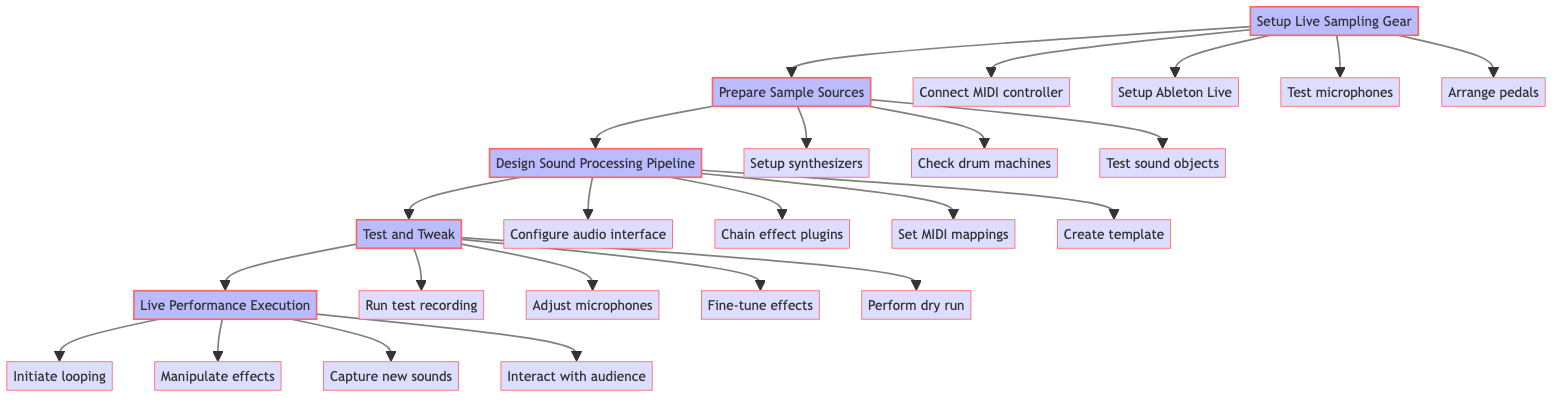What is the first step in the sequence? The first step, as the flow chart indicates, is "Setup Live Sampling Gear." There is a clear directional arrow leading from "Setup Live Sampling Gear" to the next step, indicating the order of operations.
Answer: Setup Live Sampling Gear How many main steps are there in the diagram? The diagram contains five main steps, which are visually separated with arrows. They include Setup Live Sampling Gear, Prepare Sample Sources, Design Sound Processing Pipeline, Test and Tweak, and Live Performance Execution.
Answer: Five What follows after "Prepare Sample Sources"? After "Prepare Sample Sources," the next step in the sequence, as indicated by the arrow leading from it, is "Design Sound Processing Pipeline." This flow shows the progression of tasks clearly.
Answer: Design Sound Processing Pipeline What are the subprocess steps under "Test and Tweak"? The subprocess steps under "Test and Tweak" include "Run a test recording," "Adjust microphones," "Fine-tune effects," and "Perform dry run." Each subprocess is connected to "Test and Tweak" through arrows, implying they are part of the testing phase.
Answer: Run a test recording, Adjust microphones, Fine-tune effects, Perform dry run Which step involves "Dynamic manipulation of effects"? The step that involves "Dynamic manipulation of effects" is "Live Performance Execution." This step includes real-time performance actions listed in the diagram, making it clear this is where the manipulation occurs.
Answer: Live Performance Execution How many subprocesses are there for "Design Sound Processing Pipeline"? There are four subprocesses under "Design Sound Processing Pipeline," as indicated by the flow chart connections. They include "Configure audio interface," "Chain effect plugins," "Set MIDI mappings," and "Create template." Each of these subprocesses is connected to the main process.
Answer: Four What is the last step in the flow chart? The last step in the flow chart is "Live Performance Execution," which has no further steps following it. The arrows indicate it is the final action in the sequence.
Answer: Live Performance Execution Which step requires testing sound objects? The step that requires testing sound objects is "Prepare Sample Sources." This step specifically mentions checking unusual sound objects as part of its subprocesses.
Answer: Prepare Sample Sources 